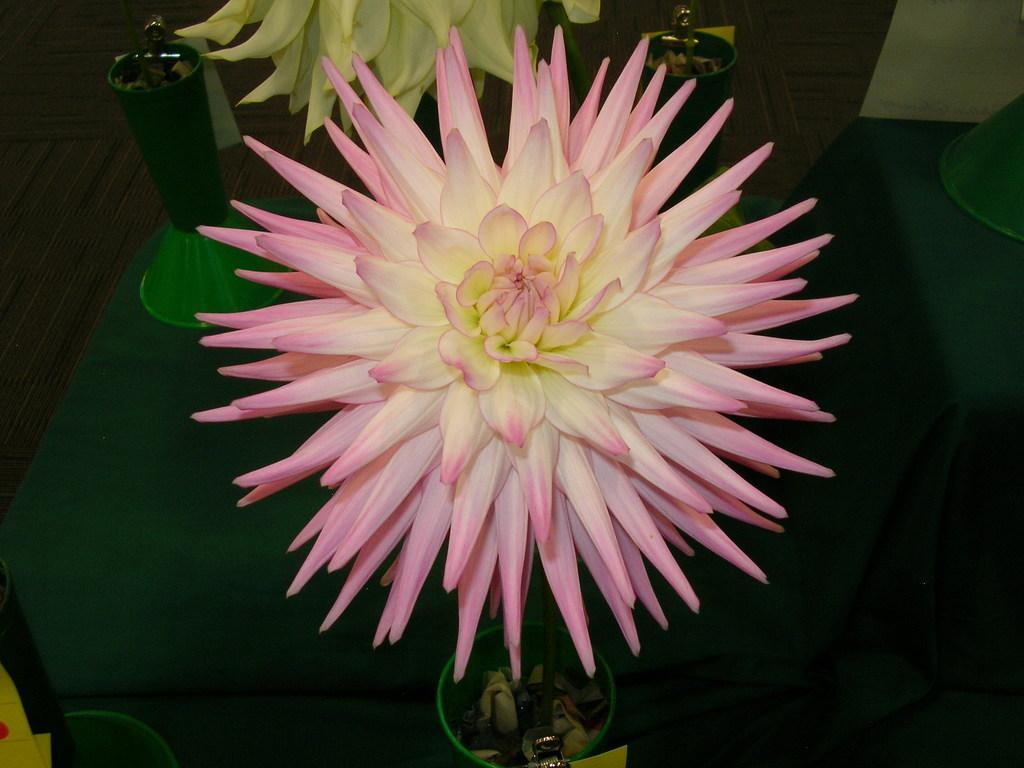Describe this image in one or two sentences. In the image we can see there is a flower which is kept on the green colour stage. 